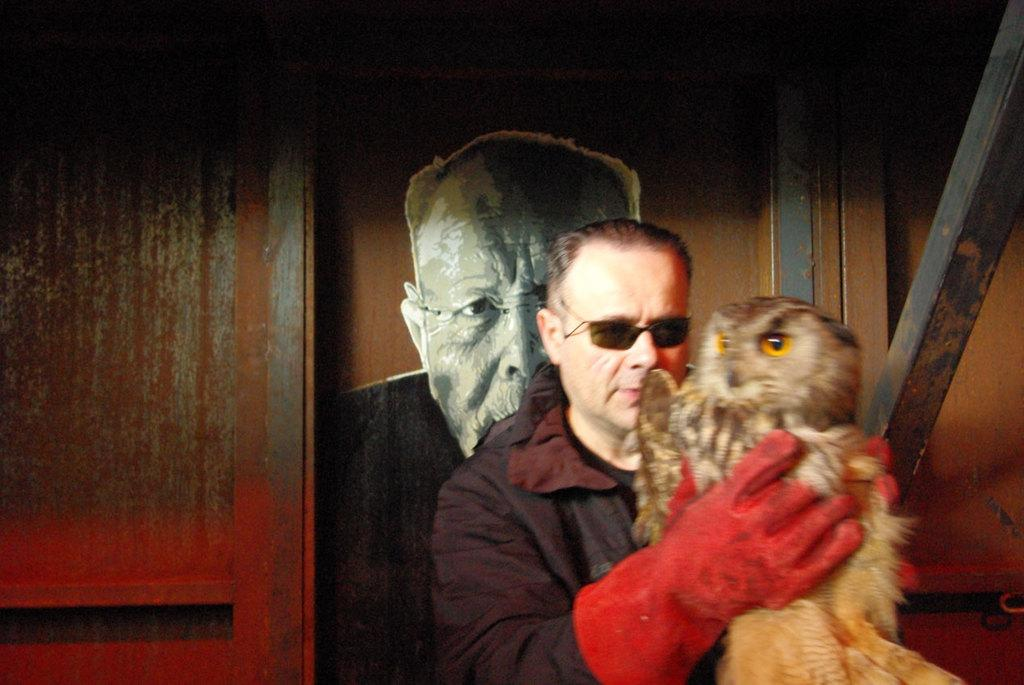What is the main subject of the image? There is a person in the image. What is the person wearing? The person is wearing a dress. What is the person holding in the image? The person is holding an owl. What can be seen in the background of the image? There is a wooden wall in the background of the image. What is on the wooden wall? There is a sticker of a person on the wooden wall. What type of hen can be seen in the image? There is no hen present in the image; the person is holding an owl. What kind of ornament is hanging from the ceiling in the image? There is no ornament hanging from the ceiling in the image. 